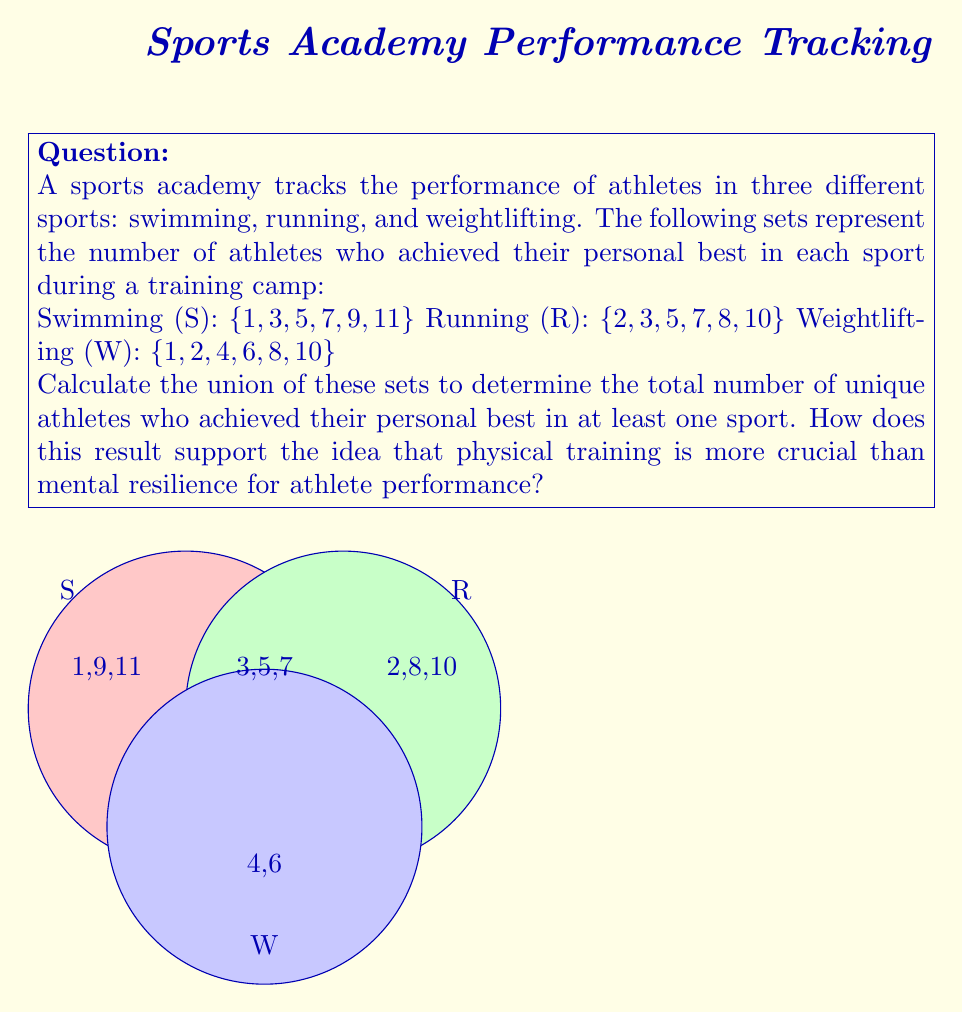What is the answer to this math problem? To solve this problem, we need to find the union of the three sets S, R, and W. The union of sets includes all unique elements that appear in any of the sets.

Step 1: List all unique elements from the three sets.
$S \cup R \cup W = \{1, 2, 3, 4, 5, 6, 7, 8, 9, 10, 11\}$

Step 2: Count the number of elements in the union set.
There are 11 unique elements in the union set.

Step 3: Interpret the result in the context of the coach's perspective.
The union set represents all athletes who achieved their personal best in at least one sport. The fact that there are 11 unique athletes out of the 18 total performances (6 in each sport) suggests that physical training has led to tangible results across different sports. This aligns with the coach's belief that physical training is more crucial than mental resilience, as the data shows concrete improvements in performance across various athletic disciplines.
Answer: $|S \cup R \cup W| = 11$ 